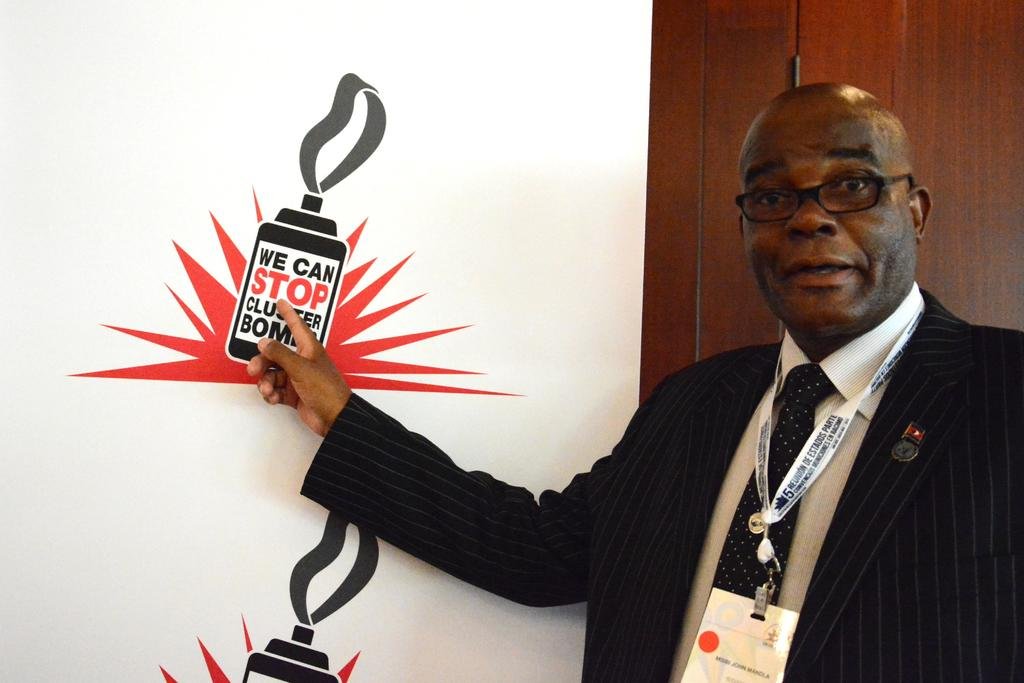Who is present in the image? There is a man in the image. What can be seen on the man? The man has a tag. What is behind the man in the image? There is a wooden door behind the man. What is on the wall on the left side of the man? There is a sticker on the wall on the left side of the man. What type of rings can be seen on the man's fingers in the image? There are no rings visible on the man's fingers in the image. What is the man's journey like in the image? The image does not depict a journey; it simply shows a man with a tag in front of a wooden door. 